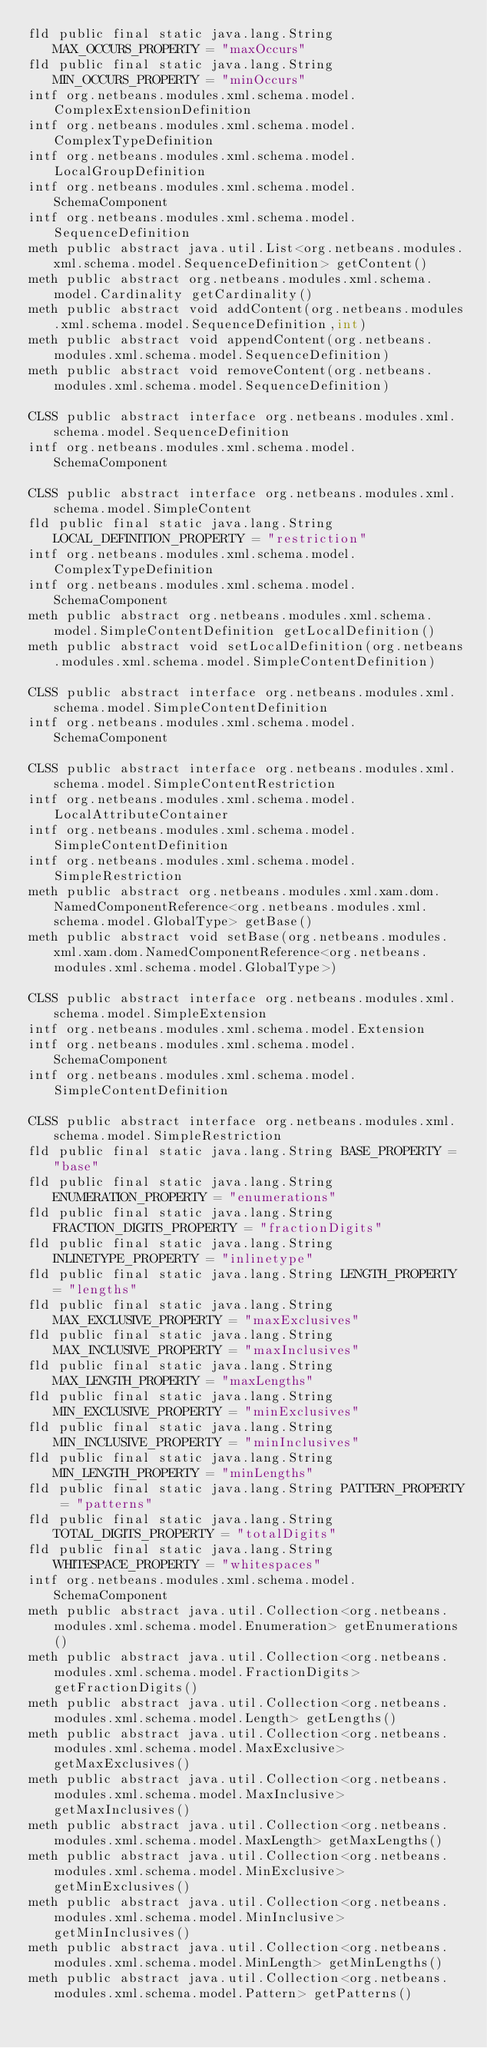<code> <loc_0><loc_0><loc_500><loc_500><_SML_>fld public final static java.lang.String MAX_OCCURS_PROPERTY = "maxOccurs"
fld public final static java.lang.String MIN_OCCURS_PROPERTY = "minOccurs"
intf org.netbeans.modules.xml.schema.model.ComplexExtensionDefinition
intf org.netbeans.modules.xml.schema.model.ComplexTypeDefinition
intf org.netbeans.modules.xml.schema.model.LocalGroupDefinition
intf org.netbeans.modules.xml.schema.model.SchemaComponent
intf org.netbeans.modules.xml.schema.model.SequenceDefinition
meth public abstract java.util.List<org.netbeans.modules.xml.schema.model.SequenceDefinition> getContent()
meth public abstract org.netbeans.modules.xml.schema.model.Cardinality getCardinality()
meth public abstract void addContent(org.netbeans.modules.xml.schema.model.SequenceDefinition,int)
meth public abstract void appendContent(org.netbeans.modules.xml.schema.model.SequenceDefinition)
meth public abstract void removeContent(org.netbeans.modules.xml.schema.model.SequenceDefinition)

CLSS public abstract interface org.netbeans.modules.xml.schema.model.SequenceDefinition
intf org.netbeans.modules.xml.schema.model.SchemaComponent

CLSS public abstract interface org.netbeans.modules.xml.schema.model.SimpleContent
fld public final static java.lang.String LOCAL_DEFINITION_PROPERTY = "restriction"
intf org.netbeans.modules.xml.schema.model.ComplexTypeDefinition
intf org.netbeans.modules.xml.schema.model.SchemaComponent
meth public abstract org.netbeans.modules.xml.schema.model.SimpleContentDefinition getLocalDefinition()
meth public abstract void setLocalDefinition(org.netbeans.modules.xml.schema.model.SimpleContentDefinition)

CLSS public abstract interface org.netbeans.modules.xml.schema.model.SimpleContentDefinition
intf org.netbeans.modules.xml.schema.model.SchemaComponent

CLSS public abstract interface org.netbeans.modules.xml.schema.model.SimpleContentRestriction
intf org.netbeans.modules.xml.schema.model.LocalAttributeContainer
intf org.netbeans.modules.xml.schema.model.SimpleContentDefinition
intf org.netbeans.modules.xml.schema.model.SimpleRestriction
meth public abstract org.netbeans.modules.xml.xam.dom.NamedComponentReference<org.netbeans.modules.xml.schema.model.GlobalType> getBase()
meth public abstract void setBase(org.netbeans.modules.xml.xam.dom.NamedComponentReference<org.netbeans.modules.xml.schema.model.GlobalType>)

CLSS public abstract interface org.netbeans.modules.xml.schema.model.SimpleExtension
intf org.netbeans.modules.xml.schema.model.Extension
intf org.netbeans.modules.xml.schema.model.SchemaComponent
intf org.netbeans.modules.xml.schema.model.SimpleContentDefinition

CLSS public abstract interface org.netbeans.modules.xml.schema.model.SimpleRestriction
fld public final static java.lang.String BASE_PROPERTY = "base"
fld public final static java.lang.String ENUMERATION_PROPERTY = "enumerations"
fld public final static java.lang.String FRACTION_DIGITS_PROPERTY = "fractionDigits"
fld public final static java.lang.String INLINETYPE_PROPERTY = "inlinetype"
fld public final static java.lang.String LENGTH_PROPERTY = "lengths"
fld public final static java.lang.String MAX_EXCLUSIVE_PROPERTY = "maxExclusives"
fld public final static java.lang.String MAX_INCLUSIVE_PROPERTY = "maxInclusives"
fld public final static java.lang.String MAX_LENGTH_PROPERTY = "maxLengths"
fld public final static java.lang.String MIN_EXCLUSIVE_PROPERTY = "minExclusives"
fld public final static java.lang.String MIN_INCLUSIVE_PROPERTY = "minInclusives"
fld public final static java.lang.String MIN_LENGTH_PROPERTY = "minLengths"
fld public final static java.lang.String PATTERN_PROPERTY = "patterns"
fld public final static java.lang.String TOTAL_DIGITS_PROPERTY = "totalDigits"
fld public final static java.lang.String WHITESPACE_PROPERTY = "whitespaces"
intf org.netbeans.modules.xml.schema.model.SchemaComponent
meth public abstract java.util.Collection<org.netbeans.modules.xml.schema.model.Enumeration> getEnumerations()
meth public abstract java.util.Collection<org.netbeans.modules.xml.schema.model.FractionDigits> getFractionDigits()
meth public abstract java.util.Collection<org.netbeans.modules.xml.schema.model.Length> getLengths()
meth public abstract java.util.Collection<org.netbeans.modules.xml.schema.model.MaxExclusive> getMaxExclusives()
meth public abstract java.util.Collection<org.netbeans.modules.xml.schema.model.MaxInclusive> getMaxInclusives()
meth public abstract java.util.Collection<org.netbeans.modules.xml.schema.model.MaxLength> getMaxLengths()
meth public abstract java.util.Collection<org.netbeans.modules.xml.schema.model.MinExclusive> getMinExclusives()
meth public abstract java.util.Collection<org.netbeans.modules.xml.schema.model.MinInclusive> getMinInclusives()
meth public abstract java.util.Collection<org.netbeans.modules.xml.schema.model.MinLength> getMinLengths()
meth public abstract java.util.Collection<org.netbeans.modules.xml.schema.model.Pattern> getPatterns()</code> 